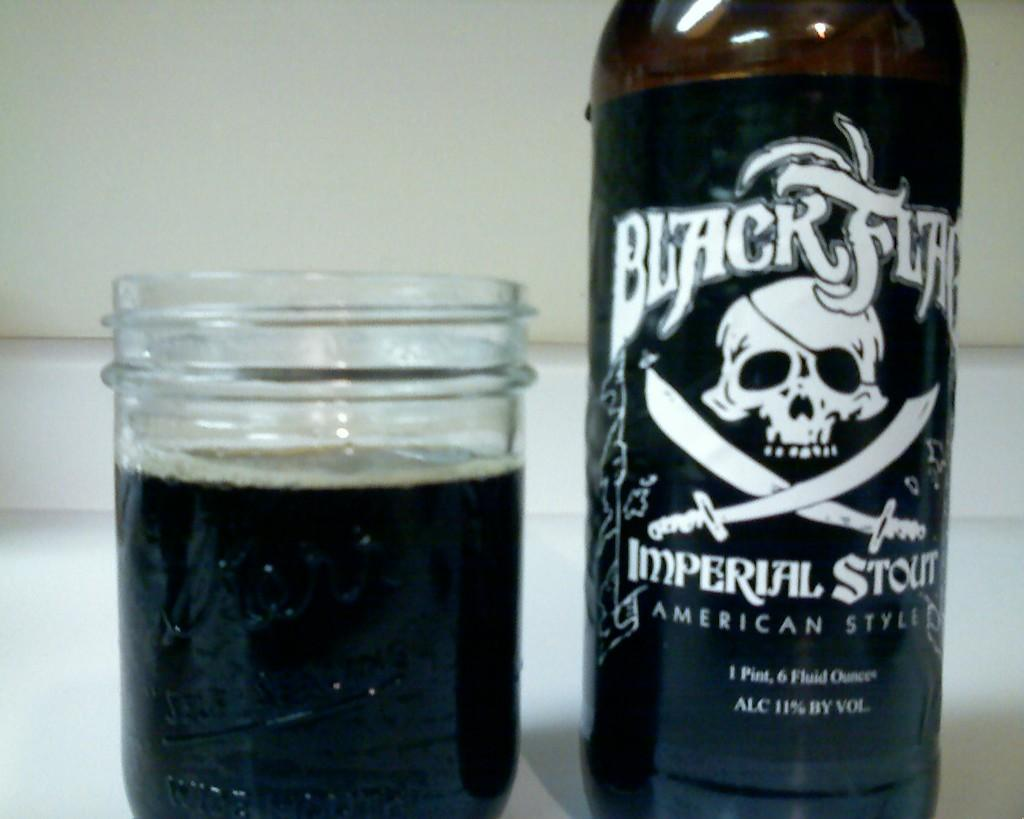<image>
Describe the image concisely. A bottle of liquid that contains 1 pint is next to a cup filled with black liquid 